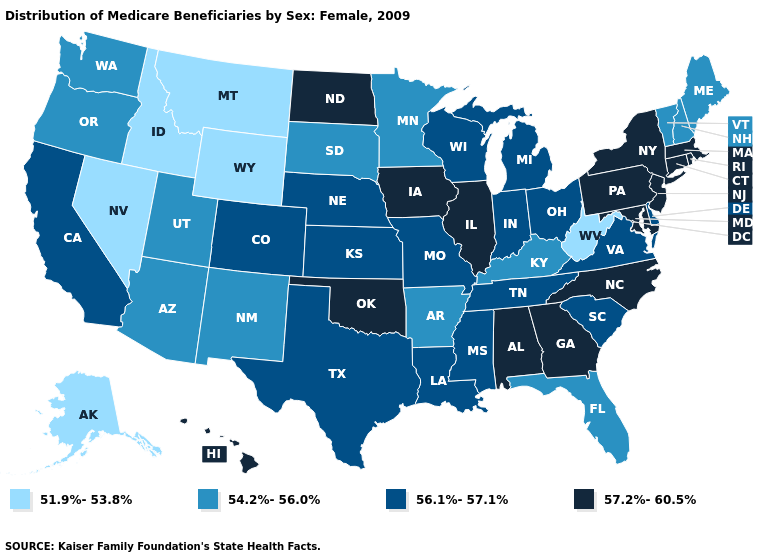What is the value of Iowa?
Write a very short answer. 57.2%-60.5%. What is the lowest value in the USA?
Concise answer only. 51.9%-53.8%. What is the value of Georgia?
Concise answer only. 57.2%-60.5%. What is the value of Vermont?
Be succinct. 54.2%-56.0%. What is the value of Oregon?
Answer briefly. 54.2%-56.0%. What is the value of Iowa?
Quick response, please. 57.2%-60.5%. What is the lowest value in the USA?
Give a very brief answer. 51.9%-53.8%. Name the states that have a value in the range 57.2%-60.5%?
Give a very brief answer. Alabama, Connecticut, Georgia, Hawaii, Illinois, Iowa, Maryland, Massachusetts, New Jersey, New York, North Carolina, North Dakota, Oklahoma, Pennsylvania, Rhode Island. Does New Mexico have the same value as Washington?
Concise answer only. Yes. What is the highest value in the West ?
Answer briefly. 57.2%-60.5%. Does Tennessee have the lowest value in the South?
Be succinct. No. Does the map have missing data?
Be succinct. No. What is the value of Alaska?
Answer briefly. 51.9%-53.8%. What is the value of South Carolina?
Answer briefly. 56.1%-57.1%. Name the states that have a value in the range 56.1%-57.1%?
Keep it brief. California, Colorado, Delaware, Indiana, Kansas, Louisiana, Michigan, Mississippi, Missouri, Nebraska, Ohio, South Carolina, Tennessee, Texas, Virginia, Wisconsin. 